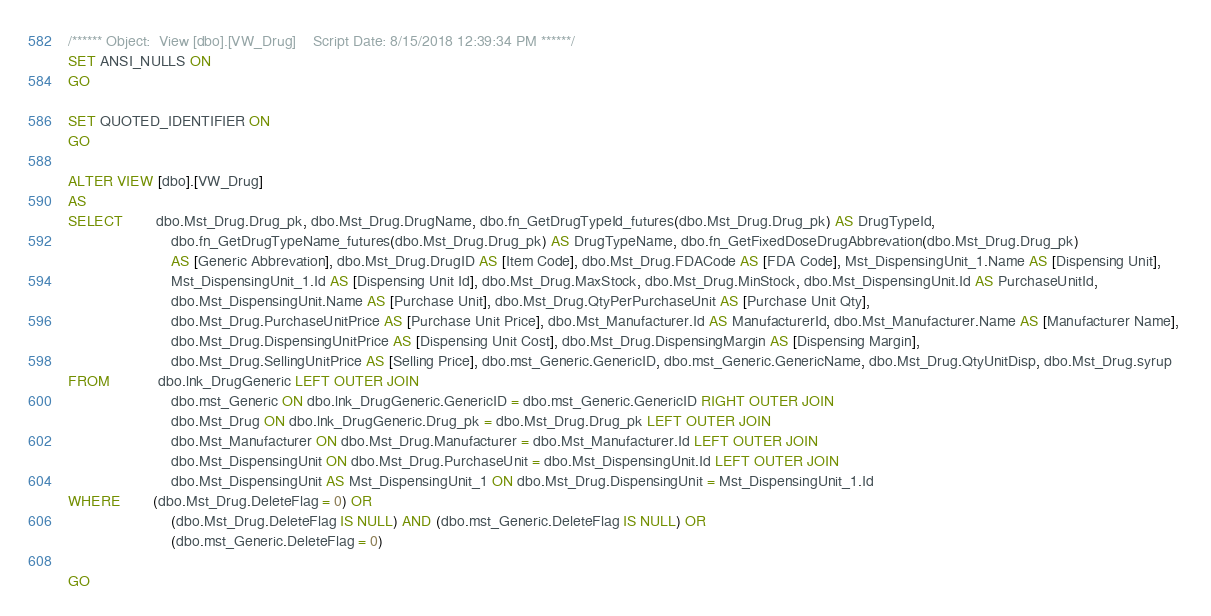<code> <loc_0><loc_0><loc_500><loc_500><_SQL_>/****** Object:  View [dbo].[VW_Drug]    Script Date: 8/15/2018 12:39:34 PM ******/
SET ANSI_NULLS ON
GO

SET QUOTED_IDENTIFIER ON
GO

ALTER VIEW [dbo].[VW_Drug]
AS
SELECT        dbo.Mst_Drug.Drug_pk, dbo.Mst_Drug.DrugName, dbo.fn_GetDrugTypeId_futures(dbo.Mst_Drug.Drug_pk) AS DrugTypeId, 
                         dbo.fn_GetDrugTypeName_futures(dbo.Mst_Drug.Drug_pk) AS DrugTypeName, dbo.fn_GetFixedDoseDrugAbbrevation(dbo.Mst_Drug.Drug_pk) 
                         AS [Generic Abbrevation], dbo.Mst_Drug.DrugID AS [Item Code], dbo.Mst_Drug.FDACode AS [FDA Code], Mst_DispensingUnit_1.Name AS [Dispensing Unit], 
                         Mst_DispensingUnit_1.Id AS [Dispensing Unit Id], dbo.Mst_Drug.MaxStock, dbo.Mst_Drug.MinStock, dbo.Mst_DispensingUnit.Id AS PurchaseUnitId, 
                         dbo.Mst_DispensingUnit.Name AS [Purchase Unit], dbo.Mst_Drug.QtyPerPurchaseUnit AS [Purchase Unit Qty], 
                         dbo.Mst_Drug.PurchaseUnitPrice AS [Purchase Unit Price], dbo.Mst_Manufacturer.Id AS ManufacturerId, dbo.Mst_Manufacturer.Name AS [Manufacturer Name], 
                         dbo.Mst_Drug.DispensingUnitPrice AS [Dispensing Unit Cost], dbo.Mst_Drug.DispensingMargin AS [Dispensing Margin], 
                         dbo.Mst_Drug.SellingUnitPrice AS [Selling Price], dbo.mst_Generic.GenericID, dbo.mst_Generic.GenericName, dbo.Mst_Drug.QtyUnitDisp, dbo.Mst_Drug.syrup
FROM            dbo.lnk_DrugGeneric LEFT OUTER JOIN
                         dbo.mst_Generic ON dbo.lnk_DrugGeneric.GenericID = dbo.mst_Generic.GenericID RIGHT OUTER JOIN
                         dbo.Mst_Drug ON dbo.lnk_DrugGeneric.Drug_pk = dbo.Mst_Drug.Drug_pk LEFT OUTER JOIN
                         dbo.Mst_Manufacturer ON dbo.Mst_Drug.Manufacturer = dbo.Mst_Manufacturer.Id LEFT OUTER JOIN
                         dbo.Mst_DispensingUnit ON dbo.Mst_Drug.PurchaseUnit = dbo.Mst_DispensingUnit.Id LEFT OUTER JOIN
                         dbo.Mst_DispensingUnit AS Mst_DispensingUnit_1 ON dbo.Mst_Drug.DispensingUnit = Mst_DispensingUnit_1.Id
WHERE        (dbo.Mst_Drug.DeleteFlag = 0) OR
                         (dbo.Mst_Drug.DeleteFlag IS NULL) AND (dbo.mst_Generic.DeleteFlag IS NULL) OR
                         (dbo.mst_Generic.DeleteFlag = 0)

GO


</code> 